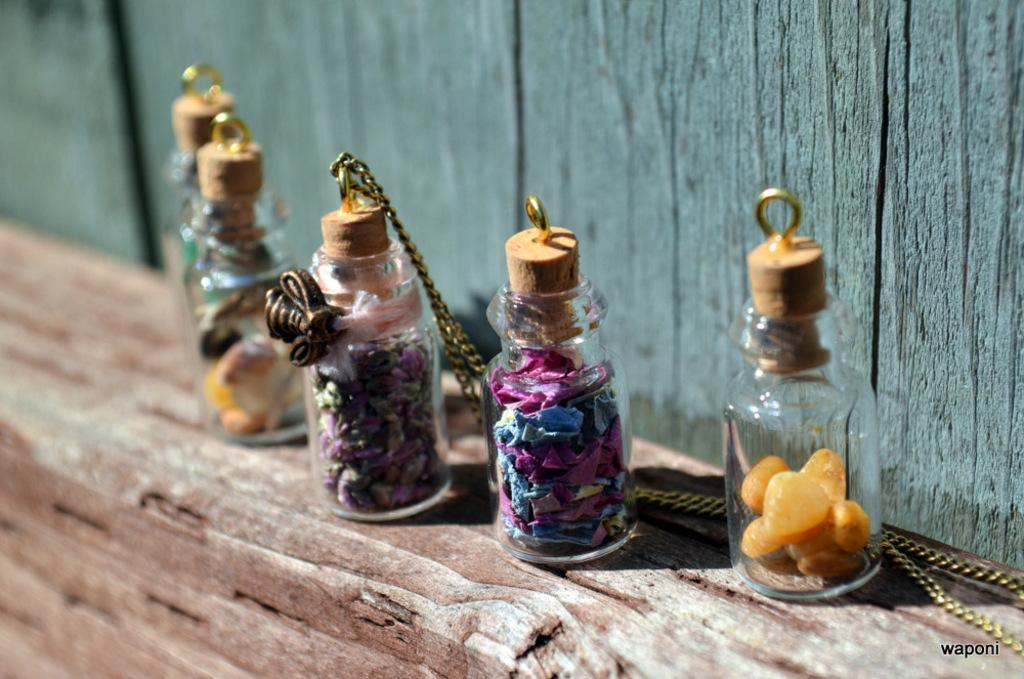How many glass jars are present in the image? There are five small glass jars in the image. What is used to close the glass jars? The glass jars are closed with small pieces of wood. What can be found inside the glass jars? There are small stones and papers inside the glass jars. Is there anything unique about one of the glass jars? One of the glass jars has a chain attached to its cap. Can you see the jeans on the person who is kicking the glass jar in the image? There is no person kicking a glass jar in the image, nor are there any jeans present. 